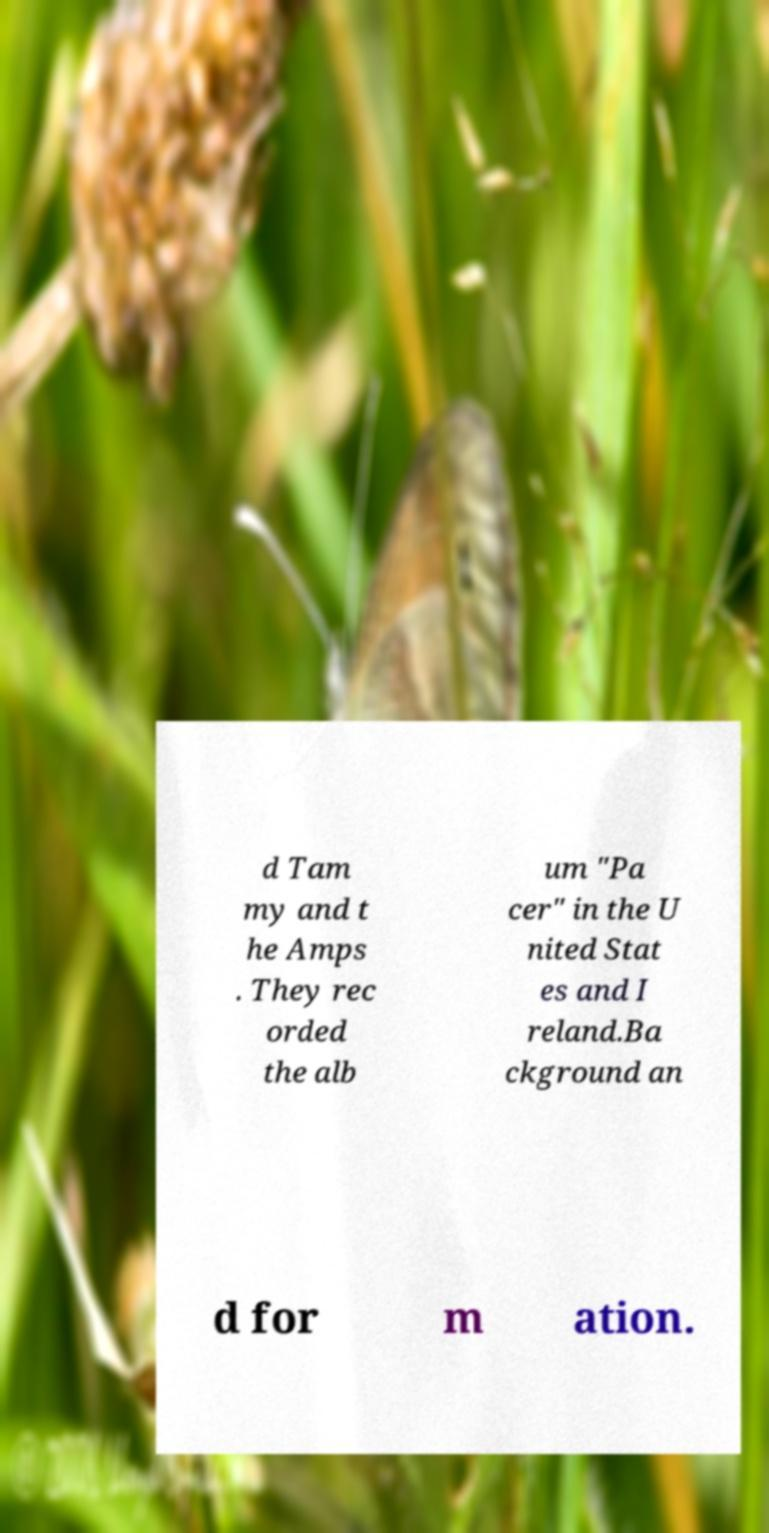There's text embedded in this image that I need extracted. Can you transcribe it verbatim? d Tam my and t he Amps . They rec orded the alb um "Pa cer" in the U nited Stat es and I reland.Ba ckground an d for m ation. 